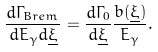Convert formula to latex. <formula><loc_0><loc_0><loc_500><loc_500>\frac { d \Gamma _ { B r e m } } { d E _ { \gamma } d \underline { \xi } } = \frac { d \Gamma _ { 0 } } { d \underline { \xi } } \frac { b ( \underline { \xi } ) } { E _ { \gamma } } .</formula> 